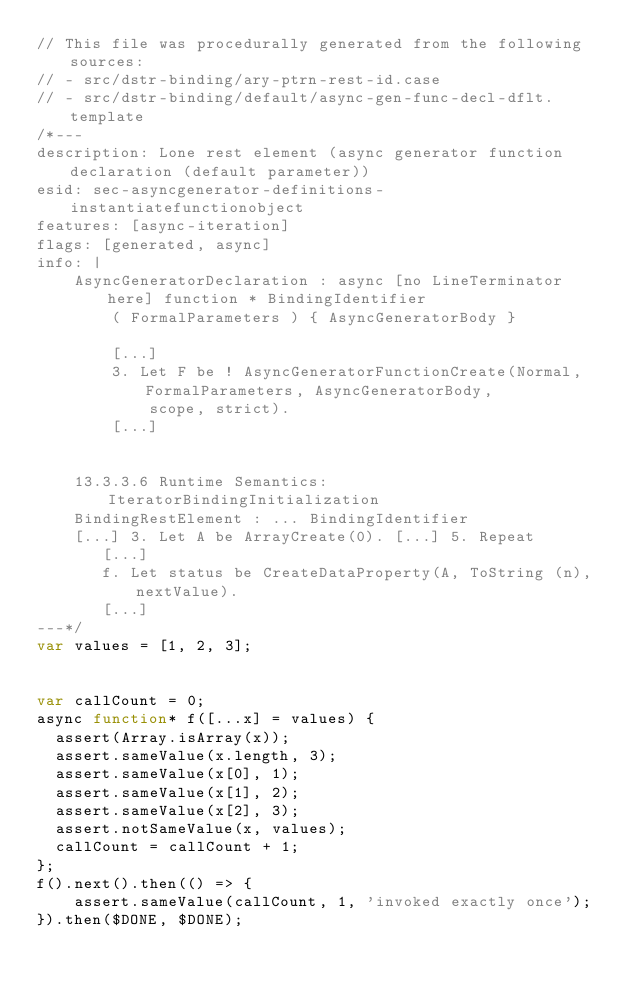Convert code to text. <code><loc_0><loc_0><loc_500><loc_500><_JavaScript_>// This file was procedurally generated from the following sources:
// - src/dstr-binding/ary-ptrn-rest-id.case
// - src/dstr-binding/default/async-gen-func-decl-dflt.template
/*---
description: Lone rest element (async generator function declaration (default parameter))
esid: sec-asyncgenerator-definitions-instantiatefunctionobject
features: [async-iteration]
flags: [generated, async]
info: |
    AsyncGeneratorDeclaration : async [no LineTerminator here] function * BindingIdentifier
        ( FormalParameters ) { AsyncGeneratorBody }

        [...]
        3. Let F be ! AsyncGeneratorFunctionCreate(Normal, FormalParameters, AsyncGeneratorBody,
            scope, strict).
        [...]


    13.3.3.6 Runtime Semantics: IteratorBindingInitialization
    BindingRestElement : ... BindingIdentifier
    [...] 3. Let A be ArrayCreate(0). [...] 5. Repeat
       [...]
       f. Let status be CreateDataProperty(A, ToString (n), nextValue).
       [...]
---*/
var values = [1, 2, 3];


var callCount = 0;
async function* f([...x] = values) {
  assert(Array.isArray(x));
  assert.sameValue(x.length, 3);
  assert.sameValue(x[0], 1);
  assert.sameValue(x[1], 2);
  assert.sameValue(x[2], 3);
  assert.notSameValue(x, values);
  callCount = callCount + 1;
};
f().next().then(() => {
    assert.sameValue(callCount, 1, 'invoked exactly once');
}).then($DONE, $DONE);
</code> 